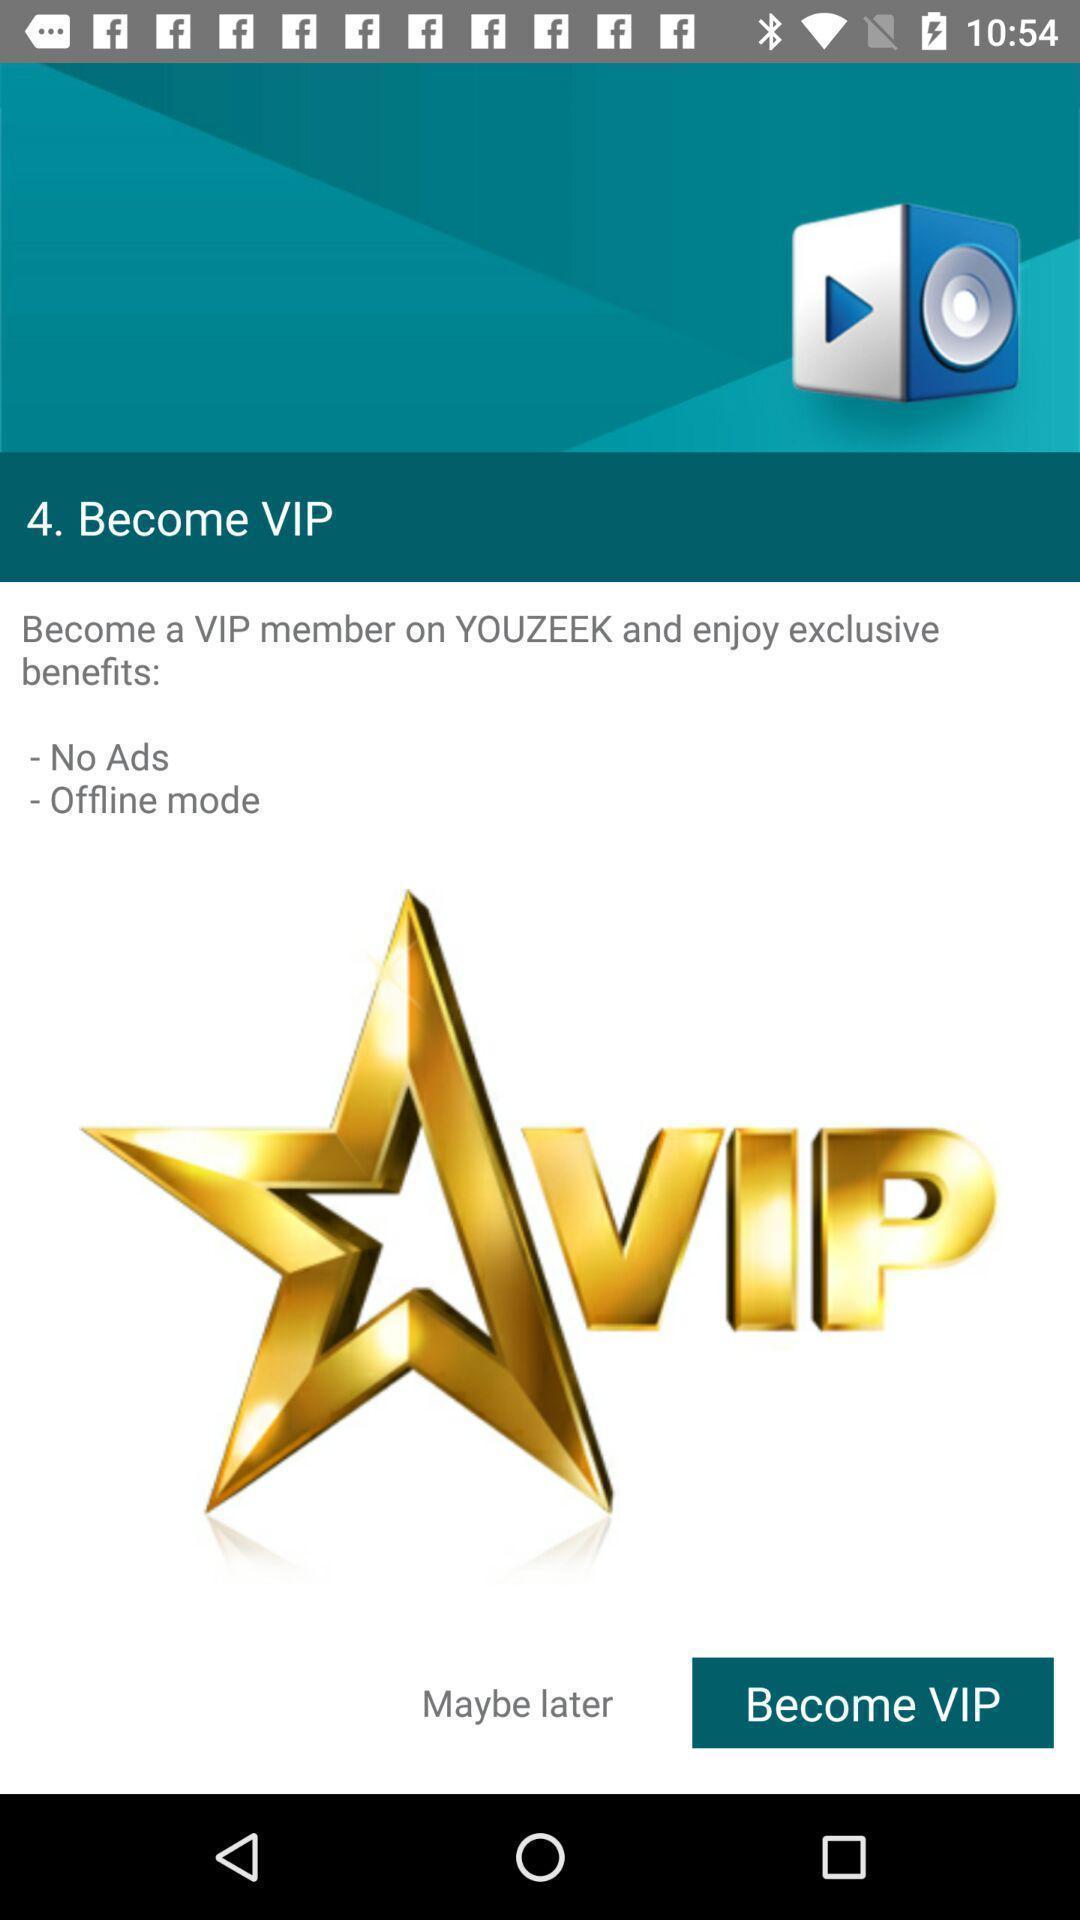Describe the key features of this screenshot. Screen displaying a membership option. 